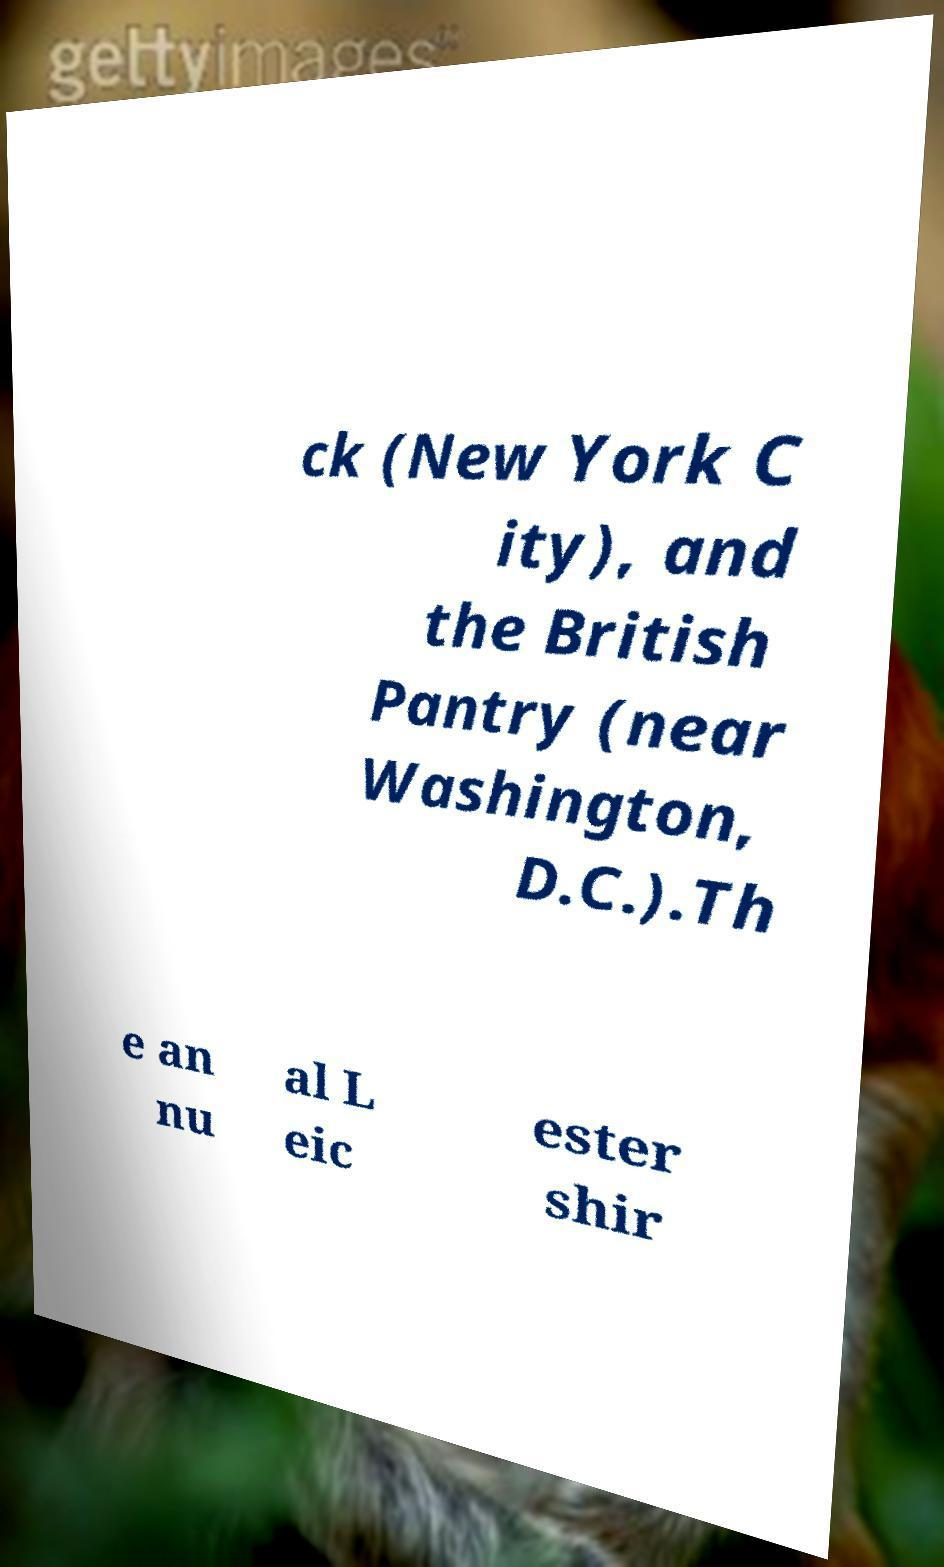For documentation purposes, I need the text within this image transcribed. Could you provide that? ck (New York C ity), and the British Pantry (near Washington, D.C.).Th e an nu al L eic ester shir 